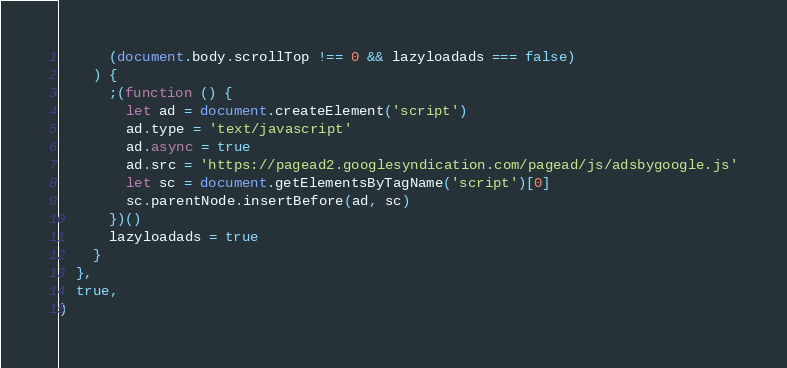<code> <loc_0><loc_0><loc_500><loc_500><_JavaScript_>      (document.body.scrollTop !== 0 && lazyloadads === false)
    ) {
      ;(function () {
        let ad = document.createElement('script')
        ad.type = 'text/javascript'
        ad.async = true
        ad.src = 'https://pagead2.googlesyndication.com/pagead/js/adsbygoogle.js'
        let sc = document.getElementsByTagName('script')[0]
        sc.parentNode.insertBefore(ad, sc)
      })()
      lazyloadads = true
    }
  },
  true,
)
</code> 